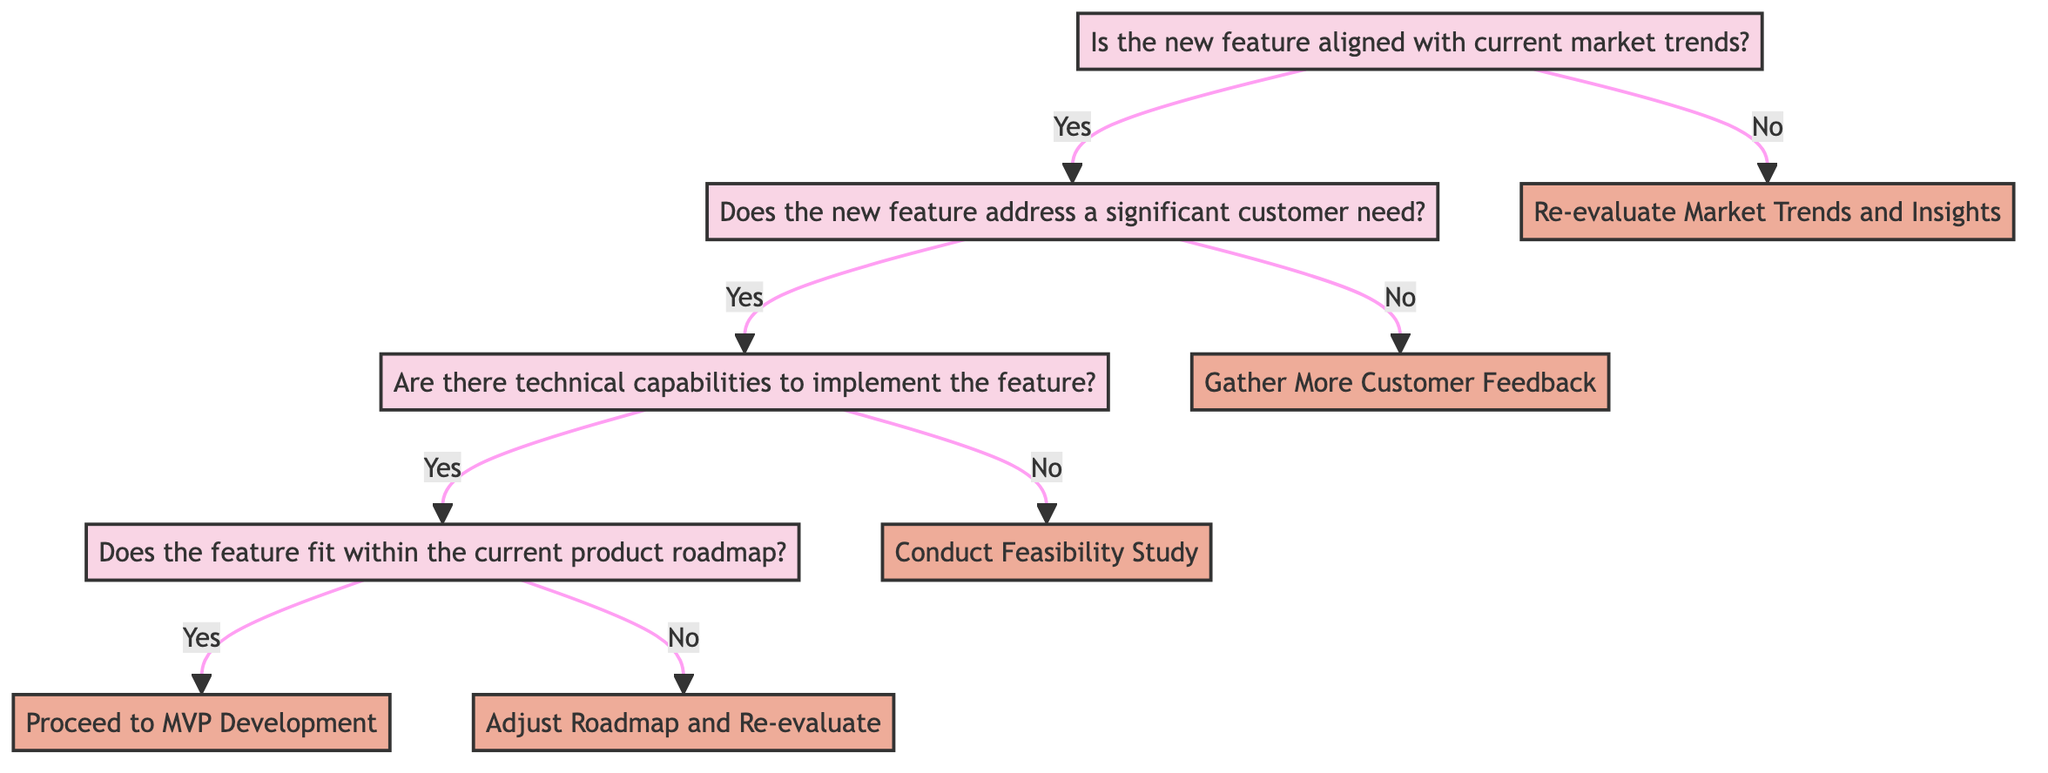What is the first question in the decision tree? The first question in the decision tree is "Is the new feature aligned with current market trends?"
Answer: Is the new feature aligned with current market trends? How many total decision nodes are in the diagram? There are four decision nodes in the diagram: the initial node and three subsequent questions.
Answer: Four What happens if the new feature does not address a significant customer need? If the new feature does not address a significant customer need, the result will be "Gather More Customer Feedback."
Answer: Gather More Customer Feedback What is the outcome if the feature fits within the current product roadmap? If the feature fits within the current product roadmap, the outcome will be "Proceed to MVP Development."
Answer: Proceed to MVP Development If the new feature is not aligned with market trends, what should be done? If the new feature is not aligned with market trends, the next step is to "Re-evaluate Market Trends and Insights."
Answer: Re-evaluate Market Trends and Insights What do you do if there are no technical capabilities to implement the feature? If there are no technical capabilities to implement the feature, the result will be "Conduct Feasibility Study."
Answer: Conduct Feasibility Study What is the relationship between the first and third questions in the decision tree? The first question determines whether to proceed to the second question, and the third question follows the second question if it is answered "yes."
Answer: The first question leads to the second, and the second leads to the third What actions result from the decision that there are technical capabilities to implement the feature? If there are technical capabilities, the next question asks whether the feature fits within the current product roadmap, which leads to further decisions.
Answer: It leads to the question about the product roadmap 